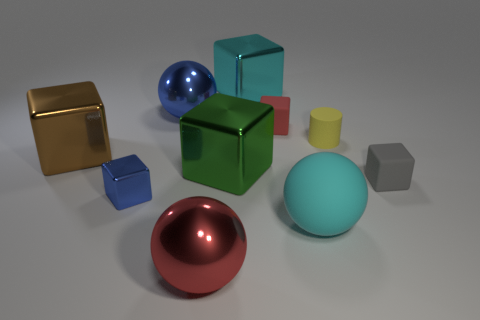Subtract all red blocks. How many blocks are left? 5 Subtract all balls. How many objects are left? 7 Subtract all cyan spheres. How many spheres are left? 2 Subtract 0 blue cylinders. How many objects are left? 10 Subtract 1 cylinders. How many cylinders are left? 0 Subtract all brown blocks. Subtract all yellow cylinders. How many blocks are left? 5 Subtract all blue cylinders. How many yellow balls are left? 0 Subtract all tiny blue cylinders. Subtract all rubber cylinders. How many objects are left? 9 Add 8 blue shiny spheres. How many blue shiny spheres are left? 9 Add 9 big cyan cubes. How many big cyan cubes exist? 10 